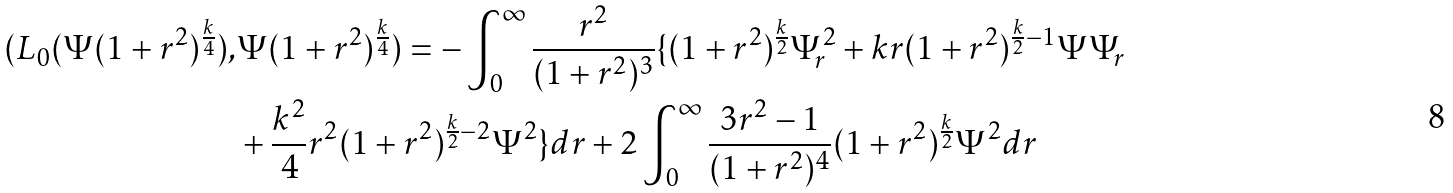Convert formula to latex. <formula><loc_0><loc_0><loc_500><loc_500>( L _ { 0 } ( \Psi ( 1 + r ^ { 2 } ) ^ { \frac { k } { 4 } } ) , & \Psi ( 1 + r ^ { 2 } ) ^ { \frac { k } { 4 } } ) = - \int _ { 0 } ^ { \infty } \frac { r ^ { 2 } } { ( 1 + r ^ { 2 } ) ^ { 3 } } \{ ( 1 + r ^ { 2 } ) ^ { \frac { k } { 2 } } \Psi _ { r } ^ { 2 } + k r ( 1 + r ^ { 2 } ) ^ { \frac { k } { 2 } - 1 } \Psi \Psi _ { r } \\ & + \frac { k ^ { 2 } } { 4 } r ^ { 2 } ( 1 + r ^ { 2 } ) ^ { \frac { k } { 2 } - 2 } \Psi ^ { 2 } \} d r + 2 \int _ { 0 } ^ { \infty } \frac { 3 r ^ { 2 } - 1 } { ( 1 + r ^ { 2 } ) ^ { 4 } } ( 1 + r ^ { 2 } ) ^ { \frac { k } { 2 } } \Psi ^ { 2 } d r \\ \</formula> 